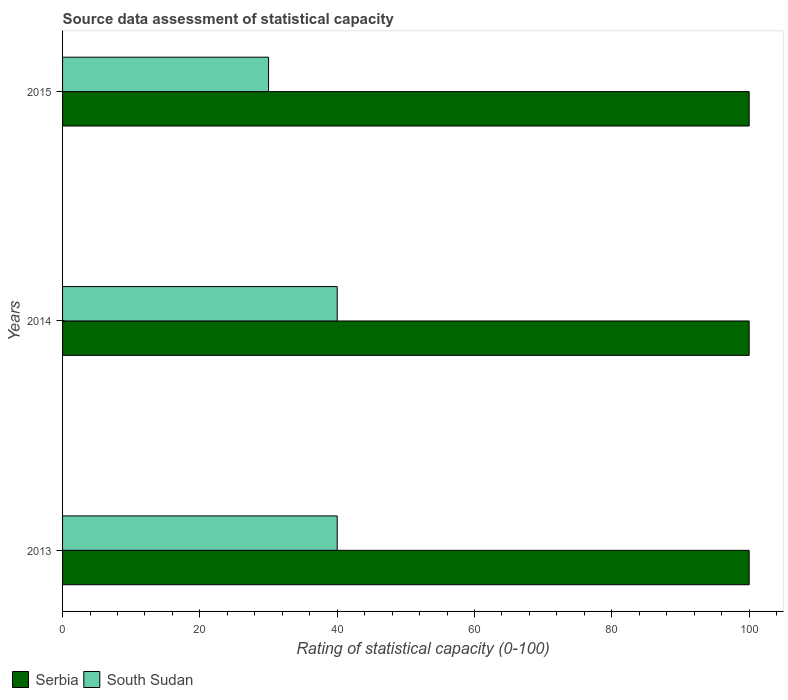How many groups of bars are there?
Offer a terse response. 3. Are the number of bars on each tick of the Y-axis equal?
Keep it short and to the point. Yes. How many bars are there on the 2nd tick from the top?
Offer a terse response. 2. What is the label of the 1st group of bars from the top?
Offer a terse response. 2015. Across all years, what is the minimum rating of statistical capacity in Serbia?
Your answer should be very brief. 100. In which year was the rating of statistical capacity in South Sudan minimum?
Make the answer very short. 2015. What is the total rating of statistical capacity in Serbia in the graph?
Offer a terse response. 300. What is the difference between the rating of statistical capacity in Serbia in 2014 and that in 2015?
Provide a short and direct response. 0. In the year 2015, what is the difference between the rating of statistical capacity in South Sudan and rating of statistical capacity in Serbia?
Offer a terse response. -70. Is the rating of statistical capacity in Serbia in 2014 less than that in 2015?
Offer a terse response. No. Is the difference between the rating of statistical capacity in South Sudan in 2013 and 2015 greater than the difference between the rating of statistical capacity in Serbia in 2013 and 2015?
Ensure brevity in your answer.  Yes. What does the 1st bar from the top in 2014 represents?
Offer a very short reply. South Sudan. What does the 2nd bar from the bottom in 2013 represents?
Make the answer very short. South Sudan. How many bars are there?
Provide a succinct answer. 6. Are all the bars in the graph horizontal?
Provide a succinct answer. Yes. How many years are there in the graph?
Provide a succinct answer. 3. Are the values on the major ticks of X-axis written in scientific E-notation?
Provide a short and direct response. No. Does the graph contain any zero values?
Your response must be concise. No. Does the graph contain grids?
Your response must be concise. No. Where does the legend appear in the graph?
Your answer should be compact. Bottom left. What is the title of the graph?
Provide a short and direct response. Source data assessment of statistical capacity. Does "New Caledonia" appear as one of the legend labels in the graph?
Your answer should be compact. No. What is the label or title of the X-axis?
Offer a terse response. Rating of statistical capacity (0-100). What is the Rating of statistical capacity (0-100) of Serbia in 2013?
Keep it short and to the point. 100. What is the Rating of statistical capacity (0-100) in South Sudan in 2013?
Give a very brief answer. 40. What is the Rating of statistical capacity (0-100) in Serbia in 2014?
Provide a short and direct response. 100. What is the Rating of statistical capacity (0-100) of South Sudan in 2014?
Your response must be concise. 40. Across all years, what is the maximum Rating of statistical capacity (0-100) of South Sudan?
Offer a terse response. 40. Across all years, what is the minimum Rating of statistical capacity (0-100) in South Sudan?
Offer a terse response. 30. What is the total Rating of statistical capacity (0-100) in Serbia in the graph?
Your response must be concise. 300. What is the total Rating of statistical capacity (0-100) of South Sudan in the graph?
Your answer should be compact. 110. What is the difference between the Rating of statistical capacity (0-100) in Serbia in 2013 and that in 2014?
Your answer should be compact. 0. What is the difference between the Rating of statistical capacity (0-100) of Serbia in 2013 and that in 2015?
Provide a short and direct response. 0. What is the difference between the Rating of statistical capacity (0-100) of South Sudan in 2013 and that in 2015?
Your answer should be compact. 10. What is the difference between the Rating of statistical capacity (0-100) in South Sudan in 2014 and that in 2015?
Make the answer very short. 10. What is the difference between the Rating of statistical capacity (0-100) in Serbia in 2014 and the Rating of statistical capacity (0-100) in South Sudan in 2015?
Make the answer very short. 70. What is the average Rating of statistical capacity (0-100) of Serbia per year?
Ensure brevity in your answer.  100. What is the average Rating of statistical capacity (0-100) of South Sudan per year?
Offer a terse response. 36.67. What is the ratio of the Rating of statistical capacity (0-100) of Serbia in 2013 to that in 2014?
Keep it short and to the point. 1. What is the ratio of the Rating of statistical capacity (0-100) of South Sudan in 2013 to that in 2015?
Provide a succinct answer. 1.33. What is the ratio of the Rating of statistical capacity (0-100) in Serbia in 2014 to that in 2015?
Ensure brevity in your answer.  1. What is the difference between the highest and the second highest Rating of statistical capacity (0-100) in Serbia?
Keep it short and to the point. 0. What is the difference between the highest and the lowest Rating of statistical capacity (0-100) in South Sudan?
Ensure brevity in your answer.  10. 